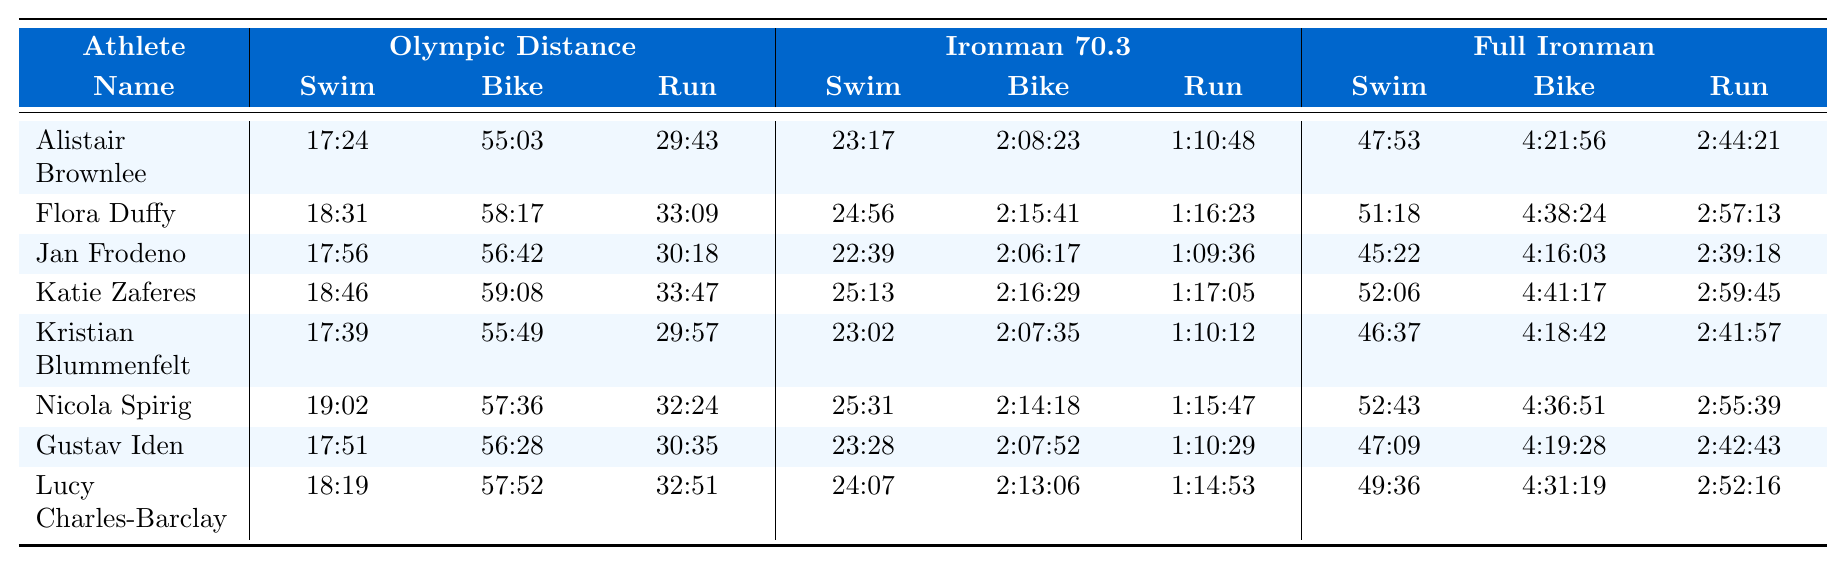What is the fastest swim time in the Olympic distance among the listed athletes? The swim times for the Olympic distance are 17:24, 18:31, 17:56, 18:46, 17:39, 19:02, 17:51, and 18:19. The lowest value is 17:24, achieved by Alistair Brownlee.
Answer: 17:24 Which athlete took the longest time to complete the run in the Ironman 70.3? The run times for the Ironman 70.3 are 1:10:48, 1:16:23, 1:09:36, 1:17:05, 1:10:12, 1:15:47, 1:10:29, and 1:14:53. The longest time is 1:17:05 by Katie Zaferes.
Answer: 1:17:05 What is the average bike time for the Olympic distance across all athletes? The bike times are 55:03, 58:17, 56:42, 59:08, 55:49, 57:36, 56:28, and 57:52. Convert these to minutes: 55.05, 58.28, 56.70, 59.13, 55.82, 57.60, 56.47, and 57.87. The sum is 457.92 minutes. Dividing by 8 gives an average of approximately 57.24 minutes, or 57 minutes and 14 seconds.
Answer: 57:14 Is Jan Frodeno's full Ironman swim time better than that of Kristian Blummenfelt? Jan Frodeno's full Ironman swim time is 45:22, while Kristian Blummenfelt's is 46:37. Since 45:22 is less than 46:37, Frodeno's time is indeed better.
Answer: Yes Which athlete has the closest split times between their Ironman 70.3 swim and bike segments? The swim times for Ironman 70.3 are 23:17, 24:56, 22:39, 25:13, 23:02, 25:31, 23:28, and 24:07, and the bike times are 2:08:23, 2:15:41, 2:06:17, 2:16:29, 2:07:35, 2:14:18, 2:07:52, and 2:13:06. The differences in time, measured in minutes from swim to bike, are respectively 105.10, 111.75, 103.63, 111.27, 104.55, 109.78, 104.40, and 109.30. Jan Frodeno has the smallest difference of approximately 103.63 minutes.
Answer: Jan Frodeno What is the total time for Alistair Brownlee to complete the full Ironman? Alistair Brownlee's times for the full Ironman are 47:53 for swim, 4:21:56 for bike, and 2:44:21 for run. The total in hours and minutes is: 47:53 + 261:56 (4:21:56) + 164:21 (2:44:21) equals 4:54:10 (sum in hours).
Answer: 4:54:10 